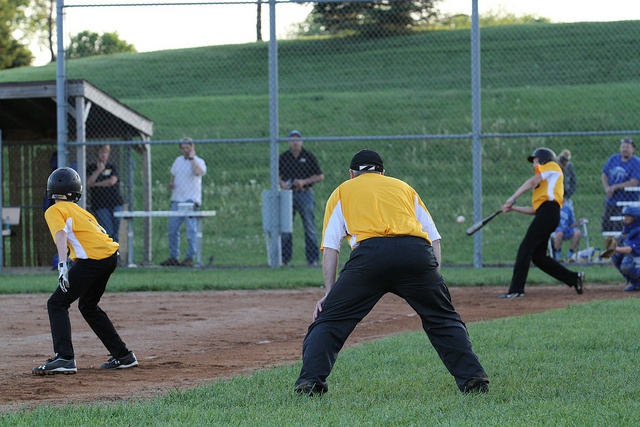Describe the objects in this image and their specific colors. I can see people in olive, black, tan, gray, and navy tones, people in olive, black, orange, tan, and darkgray tones, people in olive, black, gray, and tan tones, people in olive, black, gray, navy, and blue tones, and people in olive, darkgray, gray, and blue tones in this image. 